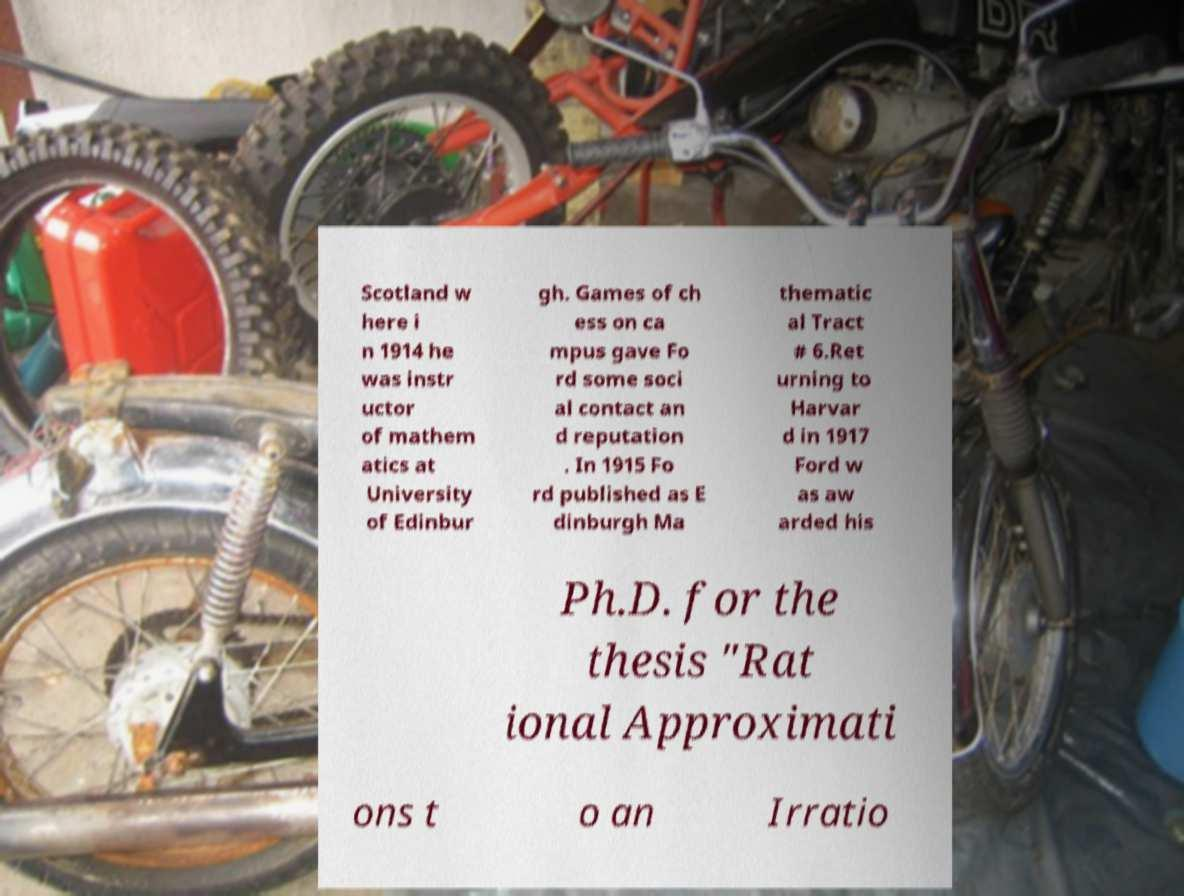Please identify and transcribe the text found in this image. Scotland w here i n 1914 he was instr uctor of mathem atics at University of Edinbur gh. Games of ch ess on ca mpus gave Fo rd some soci al contact an d reputation . In 1915 Fo rd published as E dinburgh Ma thematic al Tract # 6.Ret urning to Harvar d in 1917 Ford w as aw arded his Ph.D. for the thesis "Rat ional Approximati ons t o an Irratio 